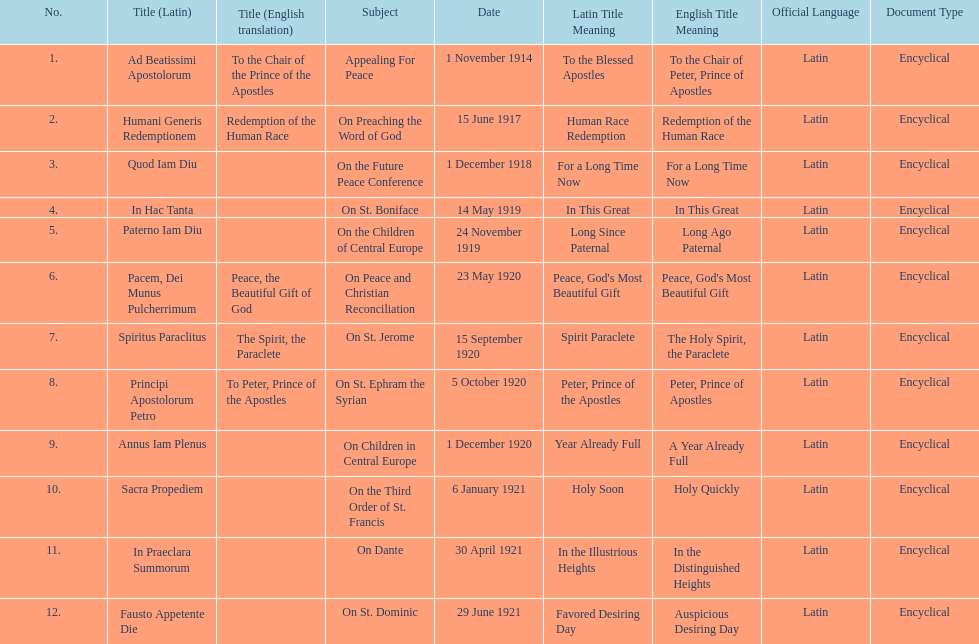What is the first english translation listed on the table? To the Chair of the Prince of the Apostles. 